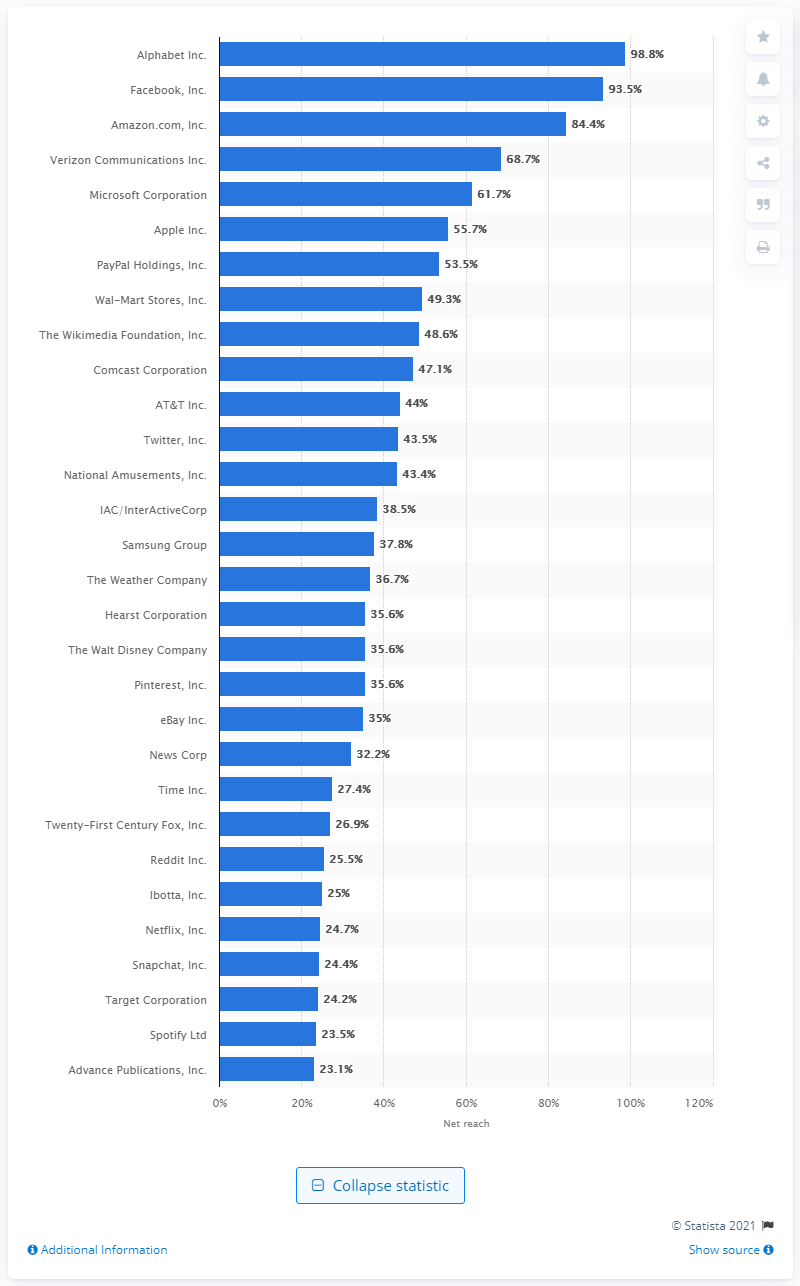Highlight a few significant elements in this photo. According to data, 98.8% of mobile users in the United States accessed Alphabet's mobile apps. 